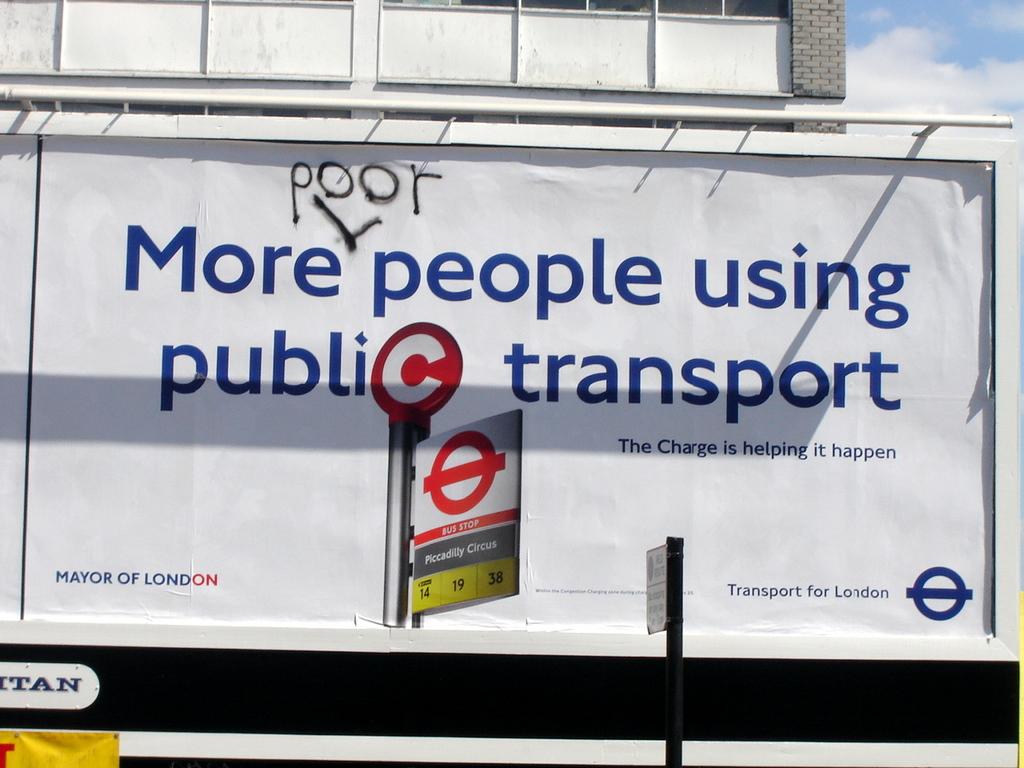Which city was this posted in?
Provide a short and direct response. London. 